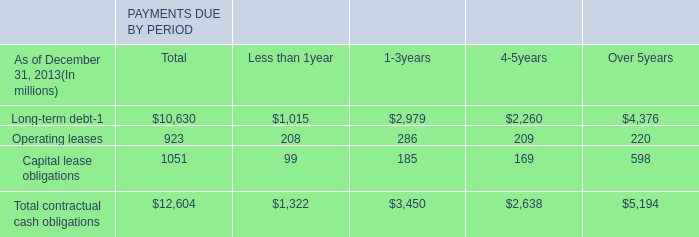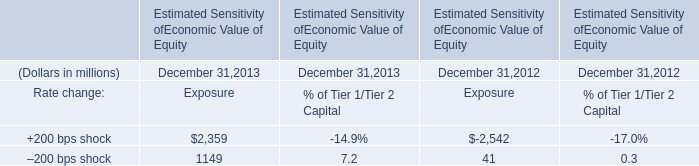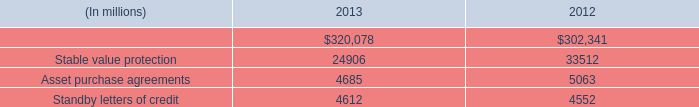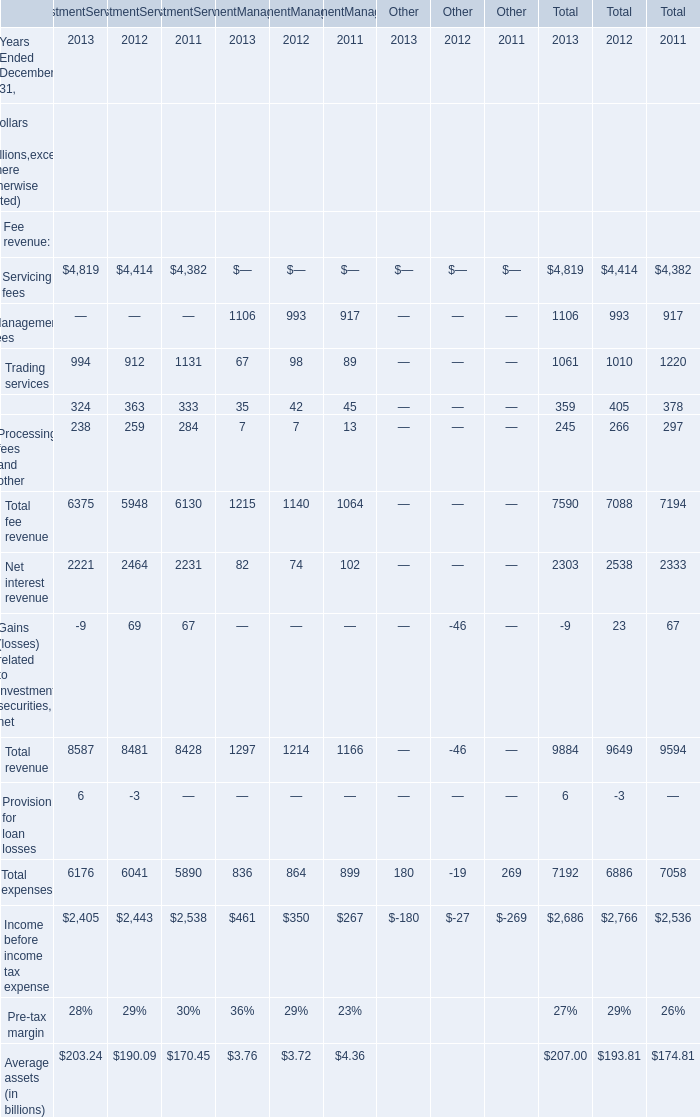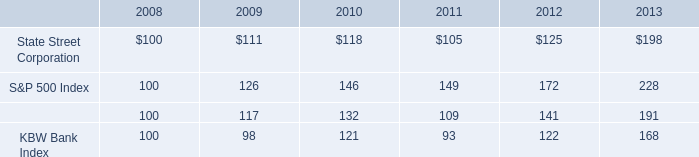how much higher are the returns of the s&p 500 in the same period ( 2008-2013 ) ? as a percentage . 
Computations: ((228 / 100) / 100)
Answer: 0.0228. 